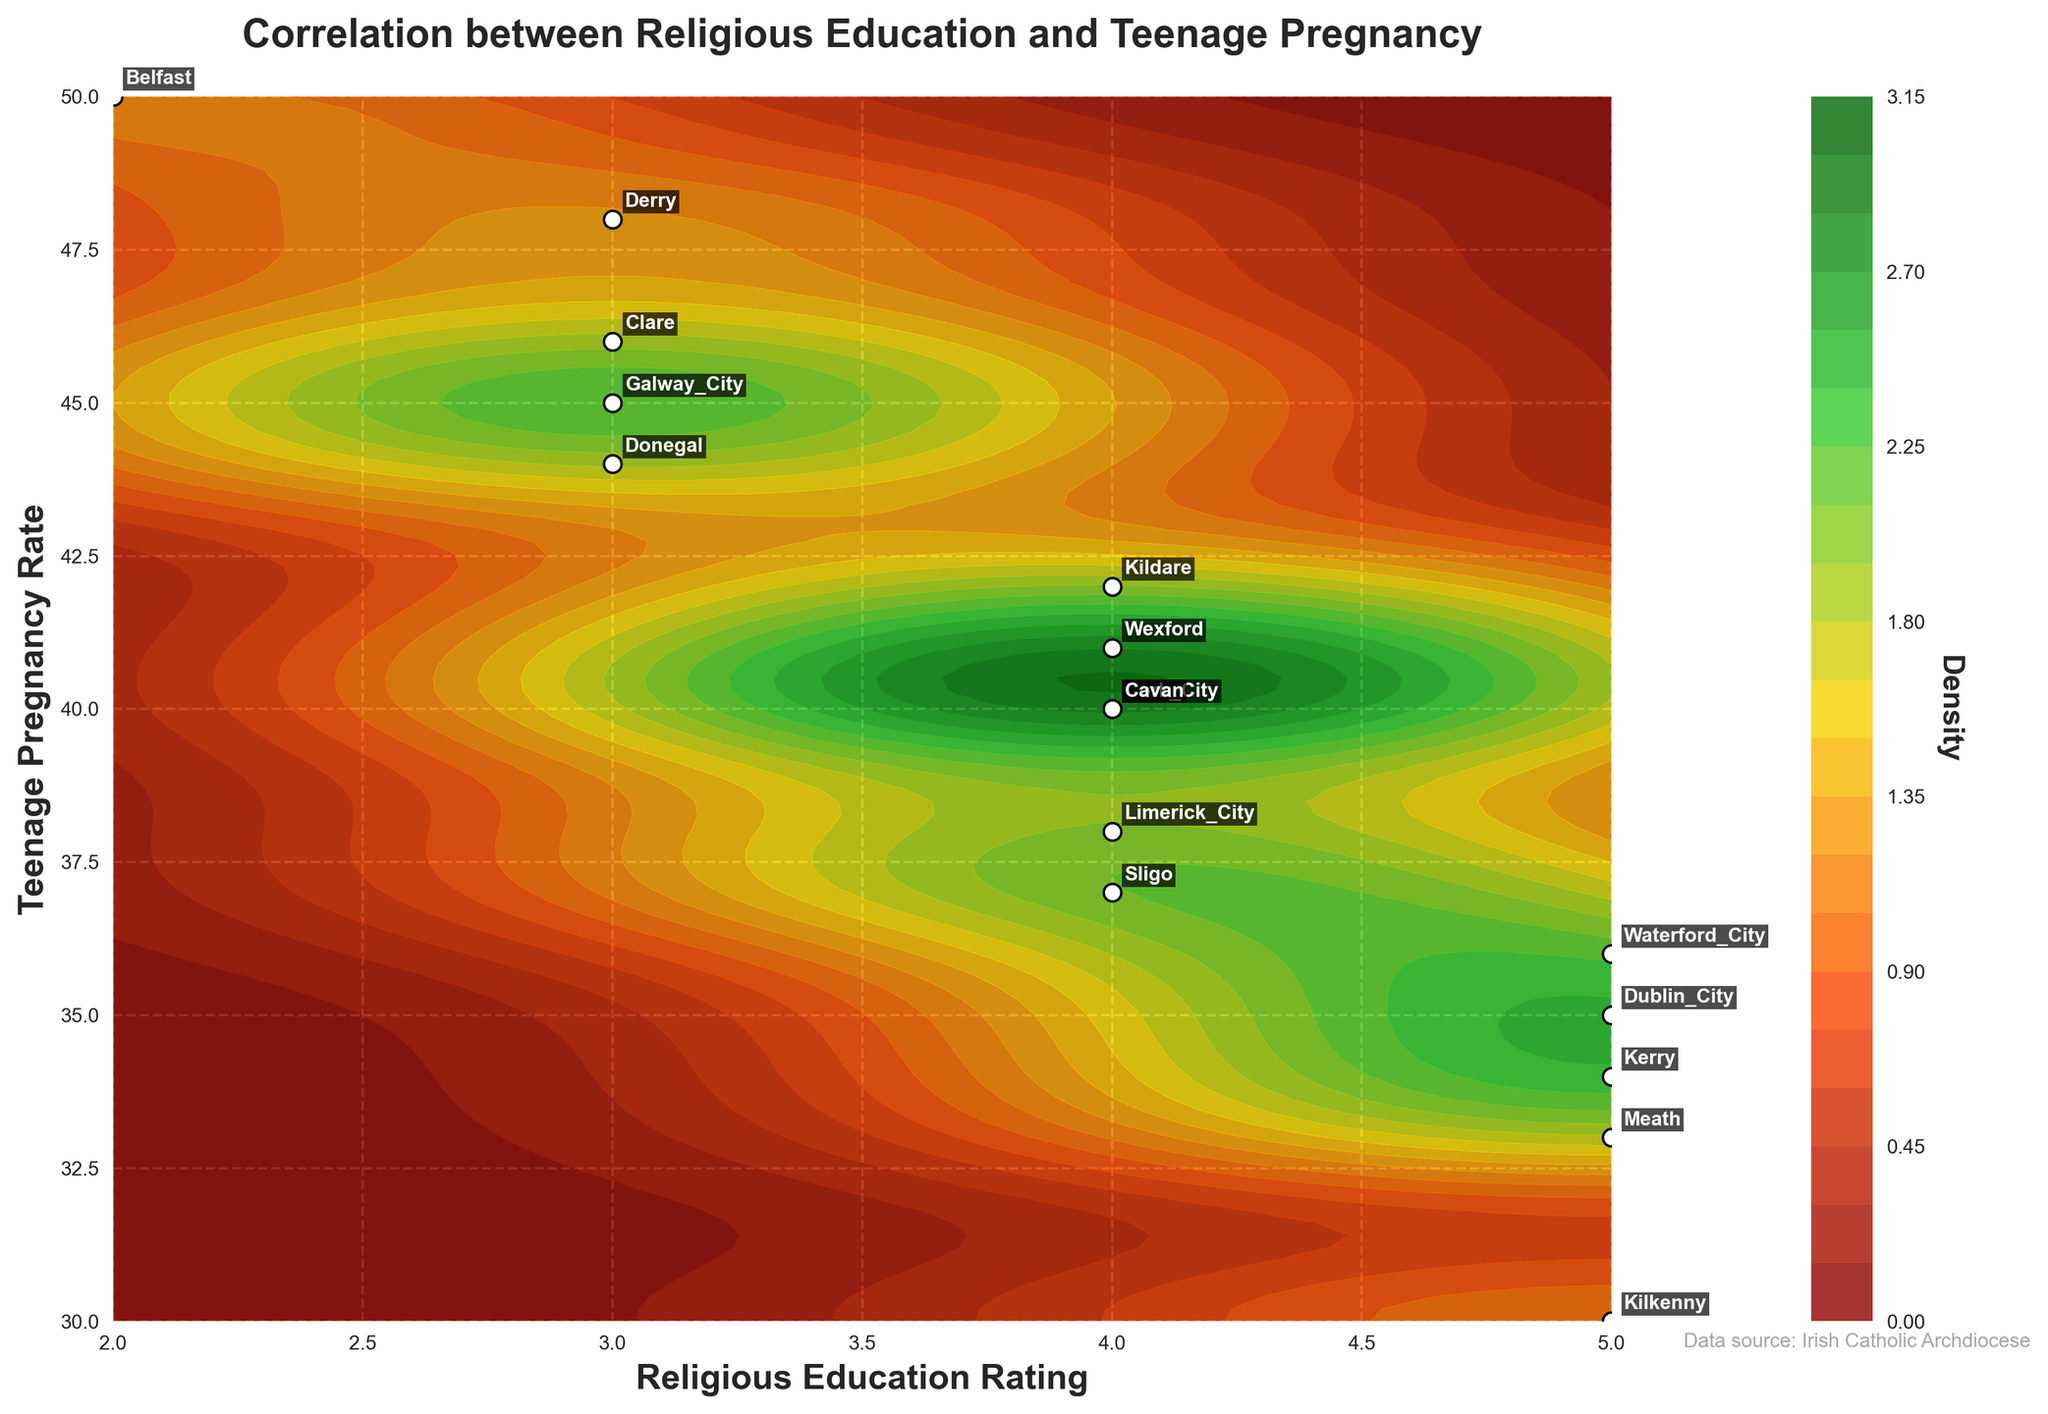What is the title of the figure? The title is usually displayed at the top of the figure and provides a succinct description of the content.
Answer: Correlation between Religious Education and Teenage Pregnancy What are the x-axis and y-axis labels in the figure? The labels for the x-axis and y-axis are typically displayed along the respective axes and indicate what the axes represent.
Answer: Religious Education Rating and Teenage Pregnancy Rate How many data points are plotted in the figure? To determine the number of data points, identify and count all the scatter points in the plot.
Answer: 16 Which region has the highest Teenage Pregnancy Rate? Locate the scatter point with the highest y-coordinate since the y-axis represents the Teenage Pregnancy Rate.
Answer: Belfast Does the plot use color to represent density? Examine the use of different colors within the contour plot areas; variations in color generally signify changes in density.
Answer: Yes Which regions are located in the area of highest density on the plot? Identify the regions annotated within the contour area with the highest density color, which is typically indicated by the darkest or most intense color.
Answer: Dublin City, Kilkenny, Waterford City, Meath, Kerry What is the lowest Religious Education Rating in the figure, and which region does it correspond to? Find the scatter point with the lowest x-coordinate since the x-axis represents the Religious Education Rating, then look for the corresponding annotated region.
Answer: 2, Belfast Compare the Teenage Pregnancy Rates between regions with a Religious Education Rating of 5. Identify the scatter points where the Religious Education Rating (x-coordinate) is 5, then compare the y-coordinates (Teenage Pregnancy Rates) of these points.
Answer: Kerry (34), Waterford City (36), Dublin City (35), Kilkenny (30), Meath (33) Is there a visible trend between the Religious Education Rating and Teenage Pregnancy Rate in the figure? Observe the general direction of the scatter points and contour lines to assess any discernible trend.
Answer: Higher Religious Education Ratings are correlated with lower Teenage Pregnancy Rates 